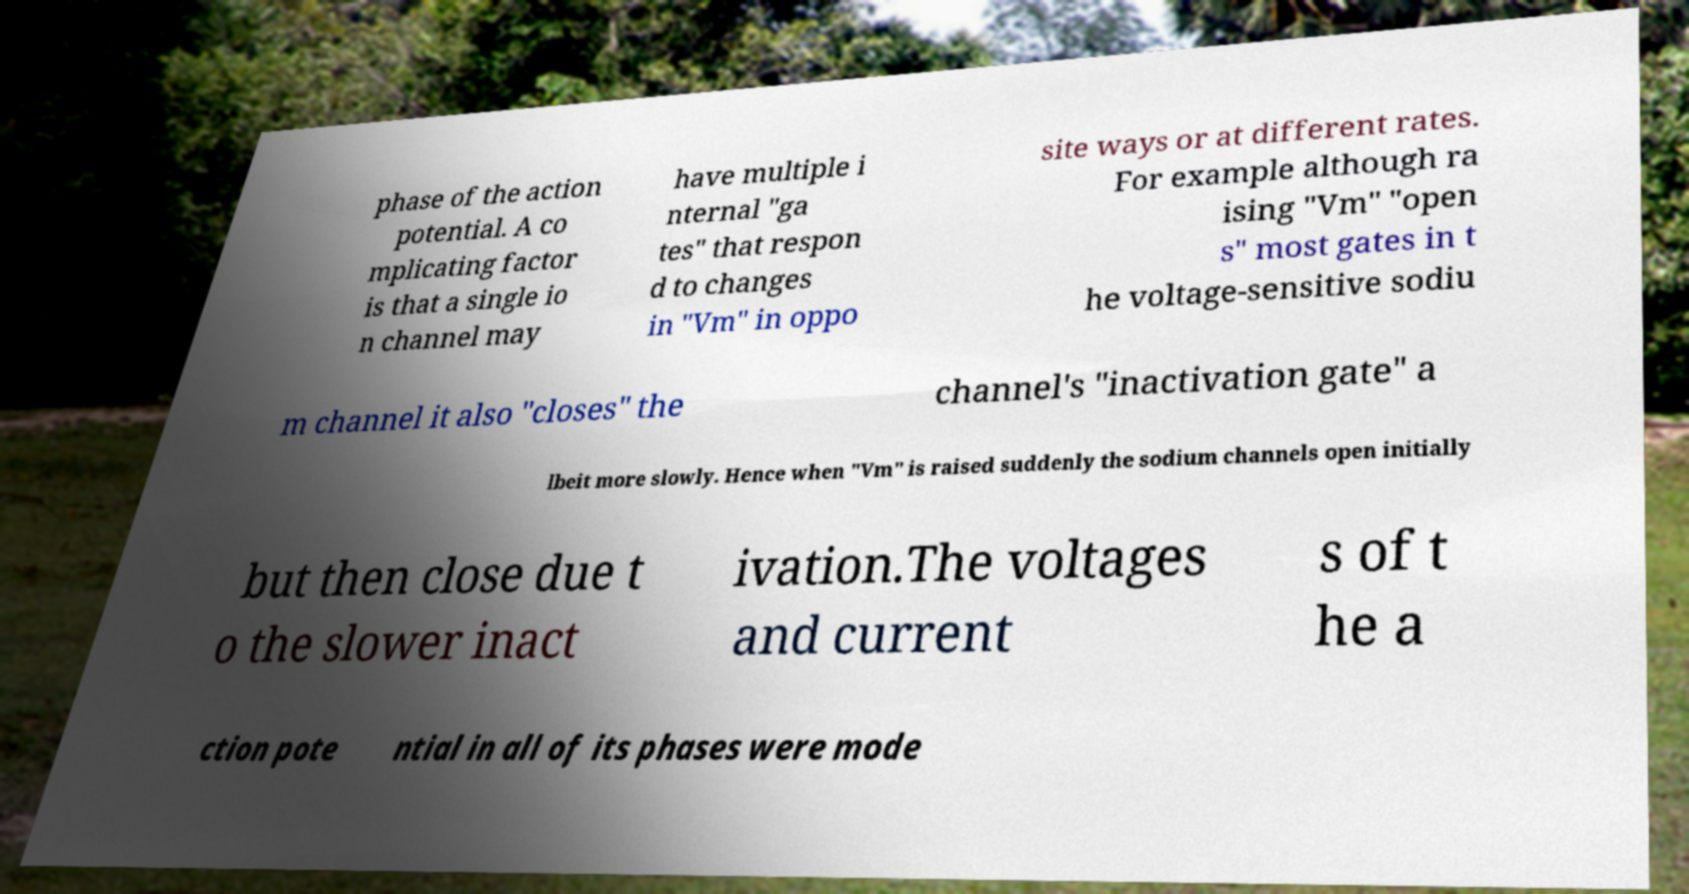Please identify and transcribe the text found in this image. phase of the action potential. A co mplicating factor is that a single io n channel may have multiple i nternal "ga tes" that respon d to changes in "Vm" in oppo site ways or at different rates. For example although ra ising "Vm" "open s" most gates in t he voltage-sensitive sodiu m channel it also "closes" the channel's "inactivation gate" a lbeit more slowly. Hence when "Vm" is raised suddenly the sodium channels open initially but then close due t o the slower inact ivation.The voltages and current s of t he a ction pote ntial in all of its phases were mode 